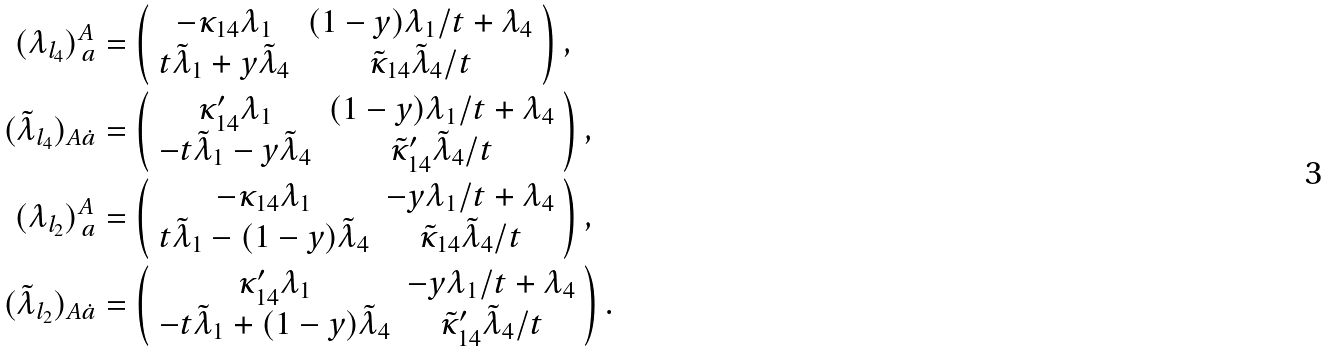Convert formula to latex. <formula><loc_0><loc_0><loc_500><loc_500>( \lambda _ { l _ { 4 } } ) ^ { A } _ { \, a } & = \left ( \begin{array} { c c } - \kappa _ { 1 4 } \lambda _ { 1 } & ( 1 - y ) \lambda _ { 1 } / t + \lambda _ { 4 } \\ t \tilde { \lambda } _ { 1 } + y \tilde { \lambda } _ { 4 } & \tilde { \kappa } _ { 1 4 } \tilde { \lambda } _ { 4 } / t \end{array} \right ) , \\ ( \tilde { \lambda } _ { l _ { 4 } } ) _ { A \dot { a } } & = \left ( \begin{array} { c c } \kappa _ { 1 4 } ^ { \prime } \lambda _ { 1 } & ( 1 - y ) \lambda _ { 1 } / t + \lambda _ { 4 } \\ - t \tilde { \lambda } _ { 1 } - y \tilde { \lambda } _ { 4 } & \tilde { \kappa } _ { 1 4 } ^ { \prime } \tilde { \lambda } _ { 4 } / t \end{array} \right ) , \\ ( \lambda _ { l _ { 2 } } ) ^ { A } _ { \, a } & = \left ( \begin{array} { c c } - \kappa _ { 1 4 } \lambda _ { 1 } & - y \lambda _ { 1 } / t + \lambda _ { 4 } \\ t \tilde { \lambda } _ { 1 } - ( 1 - y ) \tilde { \lambda } _ { 4 } & \tilde { \kappa } _ { 1 4 } \tilde { \lambda } _ { 4 } / t \end{array} \right ) , \\ ( \tilde { \lambda } _ { l _ { 2 } } ) _ { A \dot { a } } & = \left ( \begin{array} { c c } \kappa _ { 1 4 } ^ { \prime } \lambda _ { 1 } & - y \lambda _ { 1 } / t + \lambda _ { 4 } \\ - t \tilde { \lambda } _ { 1 } + ( 1 - y ) \tilde { \lambda } _ { 4 } & \tilde { \kappa } _ { 1 4 } ^ { \prime } \tilde { \lambda } _ { 4 } / t \end{array} \right ) .</formula> 